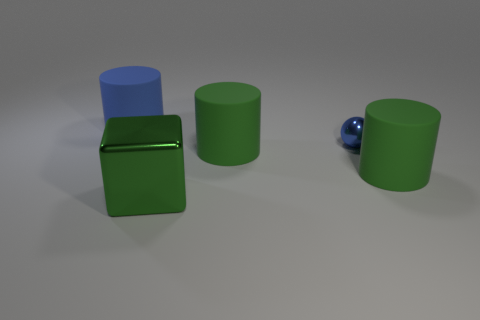There is a big object that is the same color as the small ball; what is it made of?
Your answer should be very brief. Rubber. Is there another green sphere that has the same material as the ball?
Keep it short and to the point. No. There is a object that is the same color as the metallic sphere; what is its size?
Offer a very short reply. Large. Is the number of large blue things less than the number of small gray rubber spheres?
Provide a short and direct response. No. Do the large object on the left side of the green block and the tiny metallic ball have the same color?
Keep it short and to the point. Yes. What material is the big thing that is in front of the large matte object right of the blue object that is on the right side of the big blue object?
Ensure brevity in your answer.  Metal. Are there any large cylinders that have the same color as the small shiny thing?
Make the answer very short. Yes. Are there fewer big green metallic objects that are in front of the sphere than big blue rubber cylinders?
Your answer should be compact. No. Does the green matte object that is to the right of the metallic ball have the same size as the small blue sphere?
Offer a terse response. No. How many big cylinders are on the right side of the big green shiny object and on the left side of the large green block?
Provide a short and direct response. 0. 